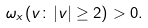Convert formula to latex. <formula><loc_0><loc_0><loc_500><loc_500>\omega _ { x } ( v \colon | v | \geq 2 ) > 0 .</formula> 